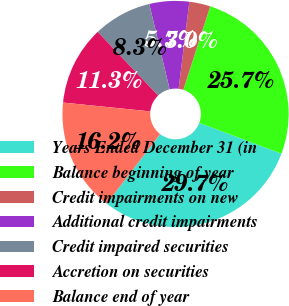<chart> <loc_0><loc_0><loc_500><loc_500><pie_chart><fcel>Years Ended December 31 (in<fcel>Balance beginning of year<fcel>Credit impairments on new<fcel>Additional credit impairments<fcel>Credit impaired securities<fcel>Accretion on securities<fcel>Balance end of year<nl><fcel>29.72%<fcel>25.75%<fcel>3.01%<fcel>5.68%<fcel>8.35%<fcel>11.31%<fcel>16.19%<nl></chart> 